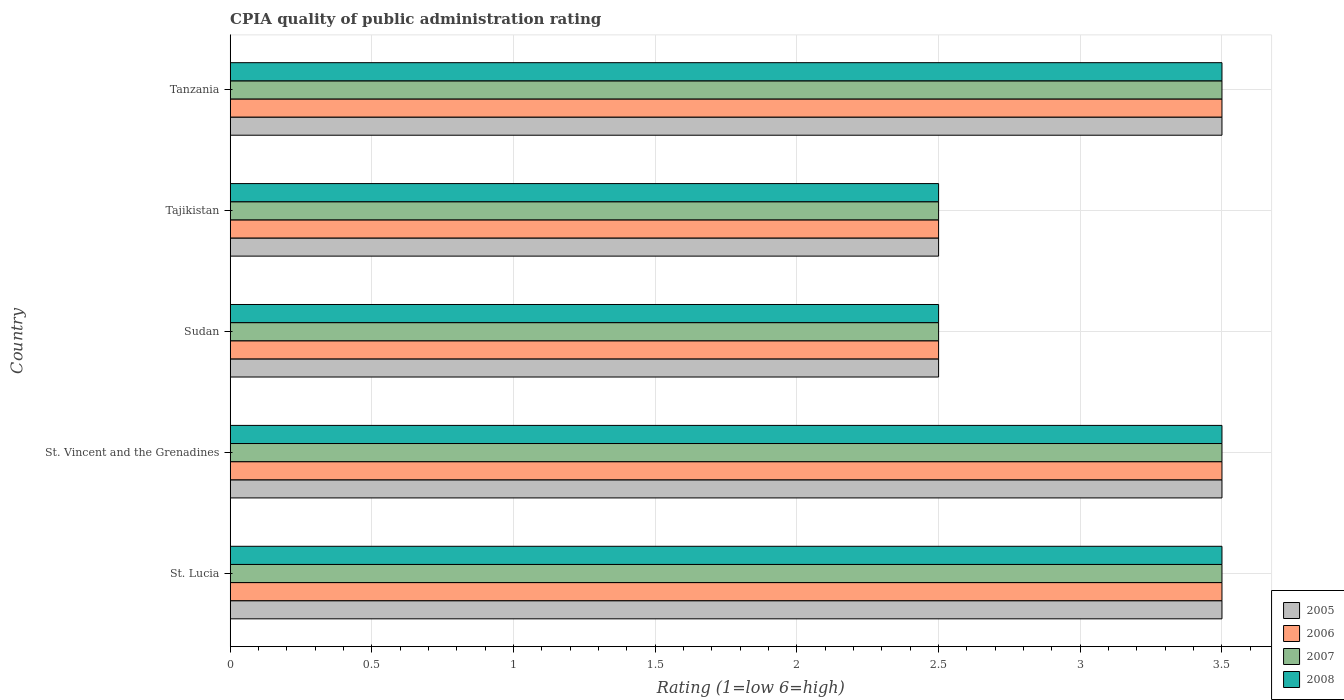How many different coloured bars are there?
Provide a short and direct response. 4. How many groups of bars are there?
Offer a very short reply. 5. Are the number of bars per tick equal to the number of legend labels?
Your answer should be compact. Yes. Are the number of bars on each tick of the Y-axis equal?
Offer a very short reply. Yes. How many bars are there on the 2nd tick from the top?
Make the answer very short. 4. What is the label of the 2nd group of bars from the top?
Keep it short and to the point. Tajikistan. In which country was the CPIA rating in 2006 maximum?
Your response must be concise. St. Lucia. In which country was the CPIA rating in 2007 minimum?
Provide a short and direct response. Sudan. What is the difference between the CPIA rating in 2006 in St. Lucia and that in Tajikistan?
Make the answer very short. 1. What is the average CPIA rating in 2007 per country?
Provide a short and direct response. 3.1. What is the difference between the CPIA rating in 2008 and CPIA rating in 2006 in St. Vincent and the Grenadines?
Provide a short and direct response. 0. What is the ratio of the CPIA rating in 2007 in Sudan to that in Tanzania?
Offer a very short reply. 0.71. Is the difference between the CPIA rating in 2008 in Tajikistan and Tanzania greater than the difference between the CPIA rating in 2006 in Tajikistan and Tanzania?
Provide a succinct answer. No. What is the difference between the highest and the second highest CPIA rating in 2007?
Your answer should be very brief. 0. What is the difference between the highest and the lowest CPIA rating in 2007?
Your answer should be very brief. 1. In how many countries, is the CPIA rating in 2006 greater than the average CPIA rating in 2006 taken over all countries?
Ensure brevity in your answer.  3. Is it the case that in every country, the sum of the CPIA rating in 2005 and CPIA rating in 2008 is greater than the sum of CPIA rating in 2006 and CPIA rating in 2007?
Your answer should be compact. No. What does the 3rd bar from the top in St. Vincent and the Grenadines represents?
Your answer should be compact. 2006. What is the difference between two consecutive major ticks on the X-axis?
Your answer should be very brief. 0.5. Are the values on the major ticks of X-axis written in scientific E-notation?
Provide a succinct answer. No. Does the graph contain any zero values?
Keep it short and to the point. No. How many legend labels are there?
Provide a succinct answer. 4. How are the legend labels stacked?
Provide a succinct answer. Vertical. What is the title of the graph?
Make the answer very short. CPIA quality of public administration rating. What is the Rating (1=low 6=high) in 2006 in St. Lucia?
Ensure brevity in your answer.  3.5. What is the Rating (1=low 6=high) in 2007 in St. Lucia?
Give a very brief answer. 3.5. What is the Rating (1=low 6=high) of 2008 in St. Lucia?
Your answer should be very brief. 3.5. What is the Rating (1=low 6=high) of 2006 in St. Vincent and the Grenadines?
Ensure brevity in your answer.  3.5. What is the Rating (1=low 6=high) in 2008 in St. Vincent and the Grenadines?
Provide a short and direct response. 3.5. What is the Rating (1=low 6=high) of 2005 in Tajikistan?
Give a very brief answer. 2.5. What is the Rating (1=low 6=high) in 2006 in Tajikistan?
Keep it short and to the point. 2.5. What is the Rating (1=low 6=high) in 2005 in Tanzania?
Your answer should be very brief. 3.5. What is the Rating (1=low 6=high) of 2006 in Tanzania?
Your response must be concise. 3.5. What is the Rating (1=low 6=high) in 2007 in Tanzania?
Keep it short and to the point. 3.5. Across all countries, what is the maximum Rating (1=low 6=high) of 2007?
Offer a very short reply. 3.5. Across all countries, what is the maximum Rating (1=low 6=high) of 2008?
Your response must be concise. 3.5. Across all countries, what is the minimum Rating (1=low 6=high) of 2005?
Your response must be concise. 2.5. Across all countries, what is the minimum Rating (1=low 6=high) in 2006?
Offer a terse response. 2.5. Across all countries, what is the minimum Rating (1=low 6=high) in 2007?
Make the answer very short. 2.5. Across all countries, what is the minimum Rating (1=low 6=high) in 2008?
Provide a succinct answer. 2.5. What is the total Rating (1=low 6=high) of 2005 in the graph?
Your response must be concise. 15.5. What is the total Rating (1=low 6=high) in 2006 in the graph?
Ensure brevity in your answer.  15.5. What is the total Rating (1=low 6=high) in 2007 in the graph?
Your answer should be very brief. 15.5. What is the total Rating (1=low 6=high) in 2008 in the graph?
Offer a very short reply. 15.5. What is the difference between the Rating (1=low 6=high) in 2005 in St. Lucia and that in St. Vincent and the Grenadines?
Offer a terse response. 0. What is the difference between the Rating (1=low 6=high) of 2006 in St. Lucia and that in St. Vincent and the Grenadines?
Keep it short and to the point. 0. What is the difference between the Rating (1=low 6=high) in 2005 in St. Lucia and that in Sudan?
Provide a succinct answer. 1. What is the difference between the Rating (1=low 6=high) in 2006 in St. Lucia and that in Sudan?
Your answer should be very brief. 1. What is the difference between the Rating (1=low 6=high) in 2008 in St. Lucia and that in Sudan?
Your answer should be compact. 1. What is the difference between the Rating (1=low 6=high) of 2006 in St. Lucia and that in Tajikistan?
Your answer should be very brief. 1. What is the difference between the Rating (1=low 6=high) in 2008 in St. Lucia and that in Tajikistan?
Your response must be concise. 1. What is the difference between the Rating (1=low 6=high) of 2007 in St. Lucia and that in Tanzania?
Your answer should be compact. 0. What is the difference between the Rating (1=low 6=high) in 2008 in St. Lucia and that in Tanzania?
Provide a succinct answer. 0. What is the difference between the Rating (1=low 6=high) of 2005 in St. Vincent and the Grenadines and that in Sudan?
Your response must be concise. 1. What is the difference between the Rating (1=low 6=high) of 2008 in St. Vincent and the Grenadines and that in Sudan?
Give a very brief answer. 1. What is the difference between the Rating (1=low 6=high) in 2006 in St. Vincent and the Grenadines and that in Tajikistan?
Ensure brevity in your answer.  1. What is the difference between the Rating (1=low 6=high) in 2008 in St. Vincent and the Grenadines and that in Tanzania?
Your answer should be very brief. 0. What is the difference between the Rating (1=low 6=high) of 2005 in Sudan and that in Tajikistan?
Your answer should be very brief. 0. What is the difference between the Rating (1=low 6=high) of 2006 in Sudan and that in Tajikistan?
Your answer should be very brief. 0. What is the difference between the Rating (1=low 6=high) in 2008 in Sudan and that in Tajikistan?
Make the answer very short. 0. What is the difference between the Rating (1=low 6=high) in 2008 in Sudan and that in Tanzania?
Provide a short and direct response. -1. What is the difference between the Rating (1=low 6=high) in 2005 in Tajikistan and that in Tanzania?
Make the answer very short. -1. What is the difference between the Rating (1=low 6=high) in 2008 in Tajikistan and that in Tanzania?
Give a very brief answer. -1. What is the difference between the Rating (1=low 6=high) in 2005 in St. Lucia and the Rating (1=low 6=high) in 2006 in St. Vincent and the Grenadines?
Give a very brief answer. 0. What is the difference between the Rating (1=low 6=high) of 2005 in St. Lucia and the Rating (1=low 6=high) of 2007 in St. Vincent and the Grenadines?
Give a very brief answer. 0. What is the difference between the Rating (1=low 6=high) in 2006 in St. Lucia and the Rating (1=low 6=high) in 2007 in St. Vincent and the Grenadines?
Your answer should be compact. 0. What is the difference between the Rating (1=low 6=high) of 2006 in St. Lucia and the Rating (1=low 6=high) of 2008 in St. Vincent and the Grenadines?
Provide a succinct answer. 0. What is the difference between the Rating (1=low 6=high) of 2005 in St. Lucia and the Rating (1=low 6=high) of 2007 in Sudan?
Your answer should be compact. 1. What is the difference between the Rating (1=low 6=high) of 2005 in St. Lucia and the Rating (1=low 6=high) of 2008 in Sudan?
Give a very brief answer. 1. What is the difference between the Rating (1=low 6=high) in 2006 in St. Lucia and the Rating (1=low 6=high) in 2008 in Sudan?
Your answer should be compact. 1. What is the difference between the Rating (1=low 6=high) in 2007 in St. Lucia and the Rating (1=low 6=high) in 2008 in Sudan?
Offer a terse response. 1. What is the difference between the Rating (1=low 6=high) of 2005 in St. Lucia and the Rating (1=low 6=high) of 2007 in Tajikistan?
Keep it short and to the point. 1. What is the difference between the Rating (1=low 6=high) in 2006 in St. Lucia and the Rating (1=low 6=high) in 2007 in Tajikistan?
Provide a succinct answer. 1. What is the difference between the Rating (1=low 6=high) of 2006 in St. Lucia and the Rating (1=low 6=high) of 2008 in Tajikistan?
Provide a short and direct response. 1. What is the difference between the Rating (1=low 6=high) in 2007 in St. Lucia and the Rating (1=low 6=high) in 2008 in Tajikistan?
Make the answer very short. 1. What is the difference between the Rating (1=low 6=high) in 2005 in St. Lucia and the Rating (1=low 6=high) in 2006 in Tanzania?
Your answer should be very brief. 0. What is the difference between the Rating (1=low 6=high) of 2005 in St. Lucia and the Rating (1=low 6=high) of 2007 in Tanzania?
Offer a terse response. 0. What is the difference between the Rating (1=low 6=high) in 2007 in St. Lucia and the Rating (1=low 6=high) in 2008 in Tanzania?
Offer a very short reply. 0. What is the difference between the Rating (1=low 6=high) in 2005 in St. Vincent and the Grenadines and the Rating (1=low 6=high) in 2006 in Sudan?
Your answer should be compact. 1. What is the difference between the Rating (1=low 6=high) in 2005 in St. Vincent and the Grenadines and the Rating (1=low 6=high) in 2008 in Sudan?
Make the answer very short. 1. What is the difference between the Rating (1=low 6=high) in 2006 in St. Vincent and the Grenadines and the Rating (1=low 6=high) in 2008 in Sudan?
Offer a very short reply. 1. What is the difference between the Rating (1=low 6=high) of 2005 in St. Vincent and the Grenadines and the Rating (1=low 6=high) of 2007 in Tanzania?
Provide a short and direct response. 0. What is the difference between the Rating (1=low 6=high) of 2005 in St. Vincent and the Grenadines and the Rating (1=low 6=high) of 2008 in Tanzania?
Ensure brevity in your answer.  0. What is the difference between the Rating (1=low 6=high) of 2006 in St. Vincent and the Grenadines and the Rating (1=low 6=high) of 2007 in Tanzania?
Your answer should be compact. 0. What is the difference between the Rating (1=low 6=high) of 2006 in St. Vincent and the Grenadines and the Rating (1=low 6=high) of 2008 in Tanzania?
Provide a succinct answer. 0. What is the difference between the Rating (1=low 6=high) in 2005 in Sudan and the Rating (1=low 6=high) in 2006 in Tajikistan?
Provide a succinct answer. 0. What is the difference between the Rating (1=low 6=high) of 2005 in Sudan and the Rating (1=low 6=high) of 2007 in Tajikistan?
Provide a short and direct response. 0. What is the difference between the Rating (1=low 6=high) in 2005 in Sudan and the Rating (1=low 6=high) in 2008 in Tajikistan?
Keep it short and to the point. 0. What is the difference between the Rating (1=low 6=high) in 2006 in Sudan and the Rating (1=low 6=high) in 2007 in Tajikistan?
Keep it short and to the point. 0. What is the difference between the Rating (1=low 6=high) of 2006 in Sudan and the Rating (1=low 6=high) of 2008 in Tajikistan?
Provide a short and direct response. 0. What is the difference between the Rating (1=low 6=high) of 2005 in Sudan and the Rating (1=low 6=high) of 2006 in Tanzania?
Give a very brief answer. -1. What is the difference between the Rating (1=low 6=high) in 2006 in Sudan and the Rating (1=low 6=high) in 2008 in Tanzania?
Make the answer very short. -1. What is the difference between the Rating (1=low 6=high) of 2007 in Sudan and the Rating (1=low 6=high) of 2008 in Tanzania?
Ensure brevity in your answer.  -1. What is the difference between the Rating (1=low 6=high) of 2005 in Tajikistan and the Rating (1=low 6=high) of 2006 in Tanzania?
Your answer should be compact. -1. What is the difference between the Rating (1=low 6=high) of 2005 in Tajikistan and the Rating (1=low 6=high) of 2008 in Tanzania?
Ensure brevity in your answer.  -1. What is the difference between the Rating (1=low 6=high) of 2006 in Tajikistan and the Rating (1=low 6=high) of 2007 in Tanzania?
Your answer should be compact. -1. What is the average Rating (1=low 6=high) of 2005 per country?
Your response must be concise. 3.1. What is the average Rating (1=low 6=high) of 2008 per country?
Provide a short and direct response. 3.1. What is the difference between the Rating (1=low 6=high) of 2005 and Rating (1=low 6=high) of 2006 in St. Lucia?
Ensure brevity in your answer.  0. What is the difference between the Rating (1=low 6=high) in 2005 and Rating (1=low 6=high) in 2008 in St. Lucia?
Ensure brevity in your answer.  0. What is the difference between the Rating (1=low 6=high) of 2006 and Rating (1=low 6=high) of 2007 in St. Lucia?
Ensure brevity in your answer.  0. What is the difference between the Rating (1=low 6=high) of 2006 and Rating (1=low 6=high) of 2007 in St. Vincent and the Grenadines?
Your answer should be compact. 0. What is the difference between the Rating (1=low 6=high) of 2007 and Rating (1=low 6=high) of 2008 in St. Vincent and the Grenadines?
Offer a very short reply. 0. What is the difference between the Rating (1=low 6=high) of 2005 and Rating (1=low 6=high) of 2006 in Sudan?
Your answer should be very brief. 0. What is the difference between the Rating (1=low 6=high) of 2005 and Rating (1=low 6=high) of 2007 in Sudan?
Provide a succinct answer. 0. What is the difference between the Rating (1=low 6=high) of 2006 and Rating (1=low 6=high) of 2008 in Sudan?
Your answer should be compact. 0. What is the difference between the Rating (1=low 6=high) in 2007 and Rating (1=low 6=high) in 2008 in Sudan?
Provide a short and direct response. 0. What is the difference between the Rating (1=low 6=high) in 2005 and Rating (1=low 6=high) in 2006 in Tajikistan?
Offer a very short reply. 0. What is the difference between the Rating (1=low 6=high) in 2005 and Rating (1=low 6=high) in 2007 in Tajikistan?
Offer a very short reply. 0. What is the difference between the Rating (1=low 6=high) of 2005 and Rating (1=low 6=high) of 2008 in Tajikistan?
Provide a short and direct response. 0. What is the difference between the Rating (1=low 6=high) of 2006 and Rating (1=low 6=high) of 2007 in Tajikistan?
Offer a very short reply. 0. What is the difference between the Rating (1=low 6=high) in 2005 and Rating (1=low 6=high) in 2006 in Tanzania?
Your response must be concise. 0. What is the difference between the Rating (1=low 6=high) of 2005 and Rating (1=low 6=high) of 2007 in Tanzania?
Keep it short and to the point. 0. What is the difference between the Rating (1=low 6=high) in 2006 and Rating (1=low 6=high) in 2007 in Tanzania?
Offer a terse response. 0. What is the ratio of the Rating (1=low 6=high) in 2006 in St. Lucia to that in St. Vincent and the Grenadines?
Your response must be concise. 1. What is the ratio of the Rating (1=low 6=high) in 2007 in St. Lucia to that in St. Vincent and the Grenadines?
Give a very brief answer. 1. What is the ratio of the Rating (1=low 6=high) of 2008 in St. Lucia to that in St. Vincent and the Grenadines?
Make the answer very short. 1. What is the ratio of the Rating (1=low 6=high) of 2005 in St. Lucia to that in Sudan?
Offer a very short reply. 1.4. What is the ratio of the Rating (1=low 6=high) in 2006 in St. Lucia to that in Sudan?
Give a very brief answer. 1.4. What is the ratio of the Rating (1=low 6=high) of 2007 in St. Lucia to that in Sudan?
Keep it short and to the point. 1.4. What is the ratio of the Rating (1=low 6=high) of 2005 in St. Lucia to that in Tajikistan?
Offer a very short reply. 1.4. What is the ratio of the Rating (1=low 6=high) of 2007 in St. Lucia to that in Tajikistan?
Keep it short and to the point. 1.4. What is the ratio of the Rating (1=low 6=high) of 2008 in St. Lucia to that in Tajikistan?
Provide a short and direct response. 1.4. What is the ratio of the Rating (1=low 6=high) of 2007 in St. Lucia to that in Tanzania?
Provide a short and direct response. 1. What is the ratio of the Rating (1=low 6=high) in 2008 in St. Lucia to that in Tanzania?
Offer a very short reply. 1. What is the ratio of the Rating (1=low 6=high) of 2005 in St. Vincent and the Grenadines to that in Tajikistan?
Offer a very short reply. 1.4. What is the ratio of the Rating (1=low 6=high) in 2006 in St. Vincent and the Grenadines to that in Tajikistan?
Offer a very short reply. 1.4. What is the ratio of the Rating (1=low 6=high) in 2007 in St. Vincent and the Grenadines to that in Tajikistan?
Offer a terse response. 1.4. What is the ratio of the Rating (1=low 6=high) of 2005 in St. Vincent and the Grenadines to that in Tanzania?
Your response must be concise. 1. What is the ratio of the Rating (1=low 6=high) of 2006 in St. Vincent and the Grenadines to that in Tanzania?
Offer a terse response. 1. What is the ratio of the Rating (1=low 6=high) in 2007 in St. Vincent and the Grenadines to that in Tanzania?
Offer a terse response. 1. What is the ratio of the Rating (1=low 6=high) of 2008 in St. Vincent and the Grenadines to that in Tanzania?
Offer a very short reply. 1. What is the ratio of the Rating (1=low 6=high) in 2005 in Sudan to that in Tajikistan?
Offer a terse response. 1. What is the ratio of the Rating (1=low 6=high) in 2006 in Sudan to that in Tajikistan?
Provide a short and direct response. 1. What is the ratio of the Rating (1=low 6=high) in 2006 in Sudan to that in Tanzania?
Offer a terse response. 0.71. What is the ratio of the Rating (1=low 6=high) in 2008 in Sudan to that in Tanzania?
Your response must be concise. 0.71. What is the ratio of the Rating (1=low 6=high) in 2005 in Tajikistan to that in Tanzania?
Offer a terse response. 0.71. What is the ratio of the Rating (1=low 6=high) in 2006 in Tajikistan to that in Tanzania?
Keep it short and to the point. 0.71. What is the ratio of the Rating (1=low 6=high) in 2008 in Tajikistan to that in Tanzania?
Your answer should be compact. 0.71. What is the difference between the highest and the second highest Rating (1=low 6=high) in 2006?
Your response must be concise. 0. What is the difference between the highest and the second highest Rating (1=low 6=high) of 2007?
Your answer should be compact. 0. 